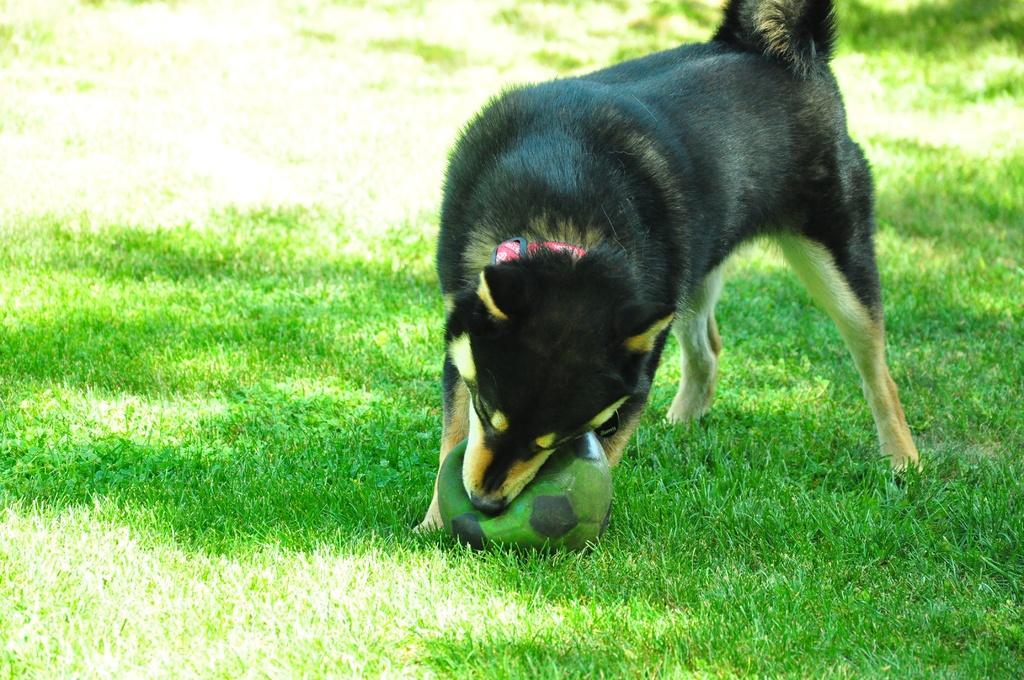Can you describe this image briefly? In this image, I can see a dog holding a ball, which is on the grass. 